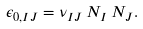<formula> <loc_0><loc_0><loc_500><loc_500>\epsilon _ { 0 , I J } = \nu _ { I J } \, N _ { I } \, N _ { J } .</formula> 